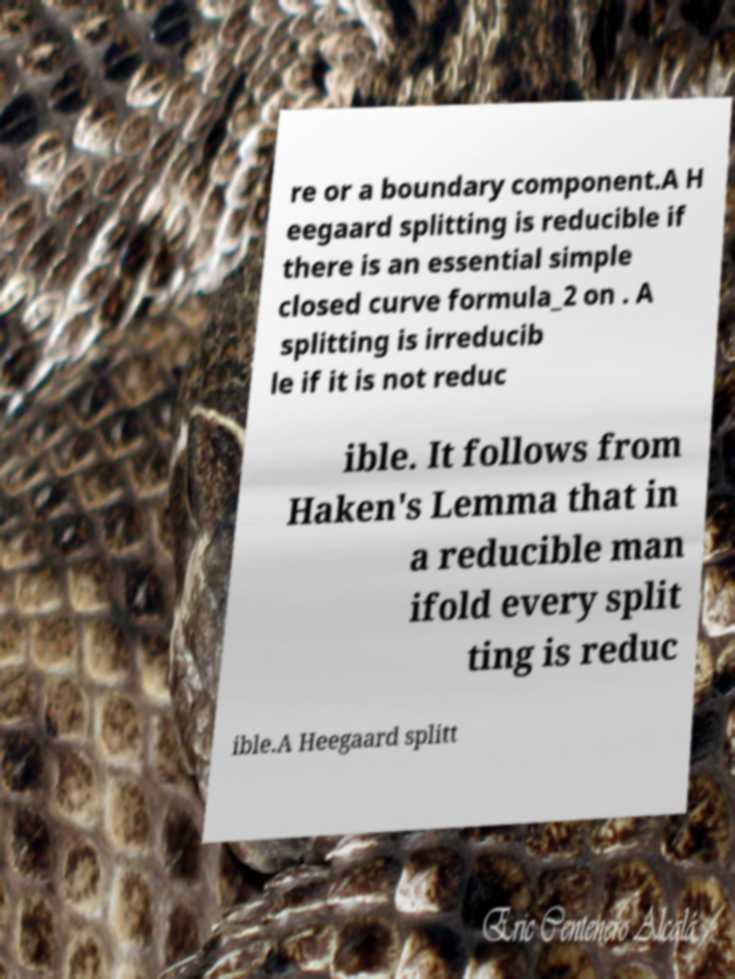There's text embedded in this image that I need extracted. Can you transcribe it verbatim? re or a boundary component.A H eegaard splitting is reducible if there is an essential simple closed curve formula_2 on . A splitting is irreducib le if it is not reduc ible. It follows from Haken's Lemma that in a reducible man ifold every split ting is reduc ible.A Heegaard splitt 